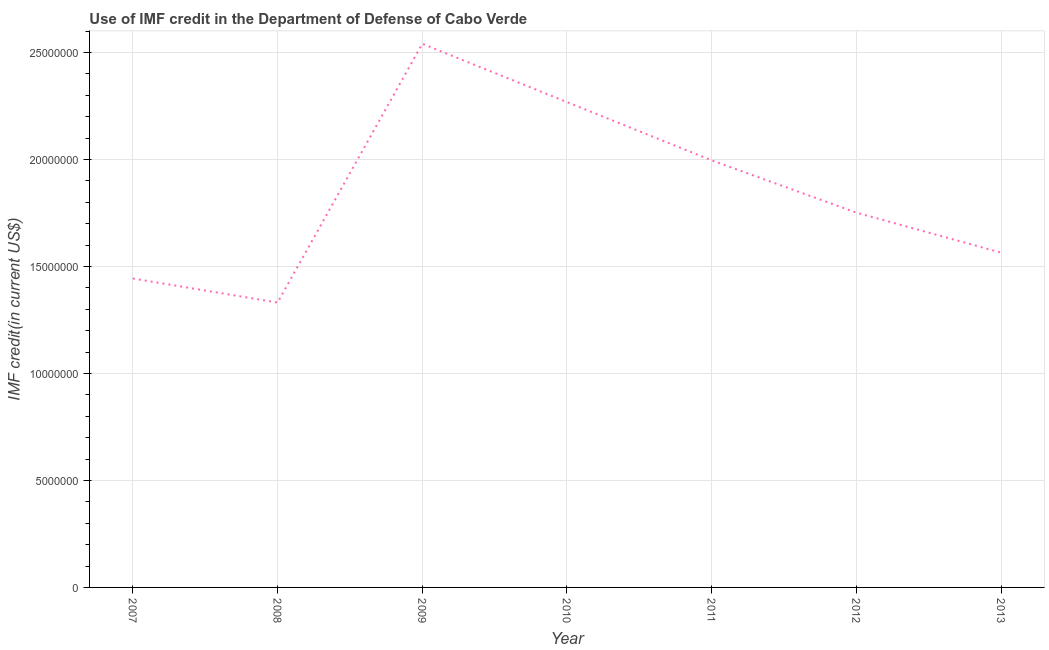What is the use of imf credit in dod in 2010?
Your response must be concise. 2.27e+07. Across all years, what is the maximum use of imf credit in dod?
Give a very brief answer. 2.54e+07. Across all years, what is the minimum use of imf credit in dod?
Your answer should be compact. 1.33e+07. In which year was the use of imf credit in dod minimum?
Your answer should be very brief. 2008. What is the sum of the use of imf credit in dod?
Offer a terse response. 1.29e+08. What is the difference between the use of imf credit in dod in 2009 and 2013?
Your answer should be very brief. 9.76e+06. What is the average use of imf credit in dod per year?
Provide a succinct answer. 1.84e+07. What is the median use of imf credit in dod?
Ensure brevity in your answer.  1.75e+07. What is the ratio of the use of imf credit in dod in 2007 to that in 2011?
Ensure brevity in your answer.  0.72. Is the use of imf credit in dod in 2010 less than that in 2012?
Keep it short and to the point. No. Is the difference between the use of imf credit in dod in 2008 and 2010 greater than the difference between any two years?
Your response must be concise. No. What is the difference between the highest and the second highest use of imf credit in dod?
Give a very brief answer. 2.73e+06. What is the difference between the highest and the lowest use of imf credit in dod?
Give a very brief answer. 1.21e+07. Does the use of imf credit in dod monotonically increase over the years?
Keep it short and to the point. No. How many lines are there?
Your response must be concise. 1. What is the difference between two consecutive major ticks on the Y-axis?
Ensure brevity in your answer.  5.00e+06. Does the graph contain grids?
Make the answer very short. Yes. What is the title of the graph?
Keep it short and to the point. Use of IMF credit in the Department of Defense of Cabo Verde. What is the label or title of the Y-axis?
Offer a very short reply. IMF credit(in current US$). What is the IMF credit(in current US$) of 2007?
Keep it short and to the point. 1.44e+07. What is the IMF credit(in current US$) of 2008?
Ensure brevity in your answer.  1.33e+07. What is the IMF credit(in current US$) of 2009?
Your answer should be very brief. 2.54e+07. What is the IMF credit(in current US$) of 2010?
Ensure brevity in your answer.  2.27e+07. What is the IMF credit(in current US$) in 2011?
Your answer should be very brief. 2.00e+07. What is the IMF credit(in current US$) in 2012?
Provide a short and direct response. 1.75e+07. What is the IMF credit(in current US$) of 2013?
Offer a terse response. 1.56e+07. What is the difference between the IMF credit(in current US$) in 2007 and 2008?
Make the answer very short. 1.12e+06. What is the difference between the IMF credit(in current US$) in 2007 and 2009?
Your response must be concise. -1.10e+07. What is the difference between the IMF credit(in current US$) in 2007 and 2010?
Ensure brevity in your answer.  -8.25e+06. What is the difference between the IMF credit(in current US$) in 2007 and 2011?
Give a very brief answer. -5.52e+06. What is the difference between the IMF credit(in current US$) in 2007 and 2012?
Your answer should be very brief. -3.08e+06. What is the difference between the IMF credit(in current US$) in 2007 and 2013?
Provide a succinct answer. -1.21e+06. What is the difference between the IMF credit(in current US$) in 2008 and 2009?
Make the answer very short. -1.21e+07. What is the difference between the IMF credit(in current US$) in 2008 and 2010?
Make the answer very short. -9.37e+06. What is the difference between the IMF credit(in current US$) in 2008 and 2011?
Your answer should be very brief. -6.65e+06. What is the difference between the IMF credit(in current US$) in 2008 and 2012?
Your answer should be very brief. -4.20e+06. What is the difference between the IMF credit(in current US$) in 2008 and 2013?
Your answer should be compact. -2.33e+06. What is the difference between the IMF credit(in current US$) in 2009 and 2010?
Offer a very short reply. 2.73e+06. What is the difference between the IMF credit(in current US$) in 2009 and 2011?
Your answer should be very brief. 5.45e+06. What is the difference between the IMF credit(in current US$) in 2009 and 2012?
Make the answer very short. 7.89e+06. What is the difference between the IMF credit(in current US$) in 2009 and 2013?
Your response must be concise. 9.76e+06. What is the difference between the IMF credit(in current US$) in 2010 and 2011?
Give a very brief answer. 2.72e+06. What is the difference between the IMF credit(in current US$) in 2010 and 2012?
Your answer should be very brief. 5.17e+06. What is the difference between the IMF credit(in current US$) in 2010 and 2013?
Ensure brevity in your answer.  7.04e+06. What is the difference between the IMF credit(in current US$) in 2011 and 2012?
Offer a very short reply. 2.44e+06. What is the difference between the IMF credit(in current US$) in 2011 and 2013?
Ensure brevity in your answer.  4.31e+06. What is the difference between the IMF credit(in current US$) in 2012 and 2013?
Provide a short and direct response. 1.87e+06. What is the ratio of the IMF credit(in current US$) in 2007 to that in 2008?
Offer a very short reply. 1.08. What is the ratio of the IMF credit(in current US$) in 2007 to that in 2009?
Your response must be concise. 0.57. What is the ratio of the IMF credit(in current US$) in 2007 to that in 2010?
Provide a succinct answer. 0.64. What is the ratio of the IMF credit(in current US$) in 2007 to that in 2011?
Ensure brevity in your answer.  0.72. What is the ratio of the IMF credit(in current US$) in 2007 to that in 2012?
Provide a succinct answer. 0.82. What is the ratio of the IMF credit(in current US$) in 2007 to that in 2013?
Ensure brevity in your answer.  0.92. What is the ratio of the IMF credit(in current US$) in 2008 to that in 2009?
Your response must be concise. 0.52. What is the ratio of the IMF credit(in current US$) in 2008 to that in 2010?
Keep it short and to the point. 0.59. What is the ratio of the IMF credit(in current US$) in 2008 to that in 2011?
Offer a terse response. 0.67. What is the ratio of the IMF credit(in current US$) in 2008 to that in 2012?
Give a very brief answer. 0.76. What is the ratio of the IMF credit(in current US$) in 2008 to that in 2013?
Provide a succinct answer. 0.85. What is the ratio of the IMF credit(in current US$) in 2009 to that in 2010?
Make the answer very short. 1.12. What is the ratio of the IMF credit(in current US$) in 2009 to that in 2011?
Make the answer very short. 1.27. What is the ratio of the IMF credit(in current US$) in 2009 to that in 2012?
Ensure brevity in your answer.  1.45. What is the ratio of the IMF credit(in current US$) in 2009 to that in 2013?
Make the answer very short. 1.62. What is the ratio of the IMF credit(in current US$) in 2010 to that in 2011?
Your answer should be very brief. 1.14. What is the ratio of the IMF credit(in current US$) in 2010 to that in 2012?
Your answer should be compact. 1.29. What is the ratio of the IMF credit(in current US$) in 2010 to that in 2013?
Provide a short and direct response. 1.45. What is the ratio of the IMF credit(in current US$) in 2011 to that in 2012?
Give a very brief answer. 1.14. What is the ratio of the IMF credit(in current US$) in 2011 to that in 2013?
Your response must be concise. 1.28. What is the ratio of the IMF credit(in current US$) in 2012 to that in 2013?
Offer a very short reply. 1.12. 